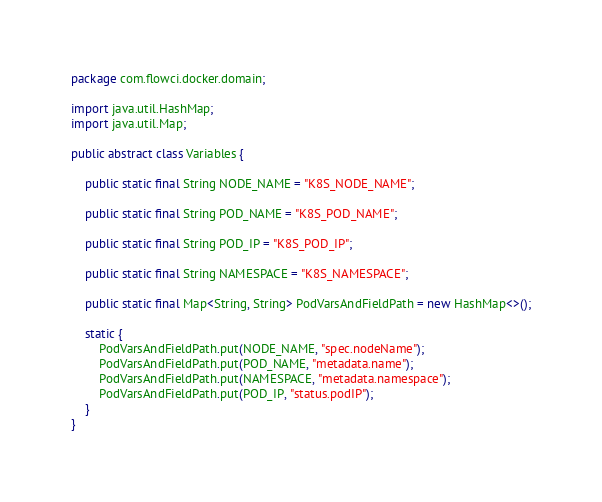Convert code to text. <code><loc_0><loc_0><loc_500><loc_500><_Java_>package com.flowci.docker.domain;

import java.util.HashMap;
import java.util.Map;

public abstract class Variables {

    public static final String NODE_NAME = "K8S_NODE_NAME";

    public static final String POD_NAME = "K8S_POD_NAME";

    public static final String POD_IP = "K8S_POD_IP";

    public static final String NAMESPACE = "K8S_NAMESPACE";

    public static final Map<String, String> PodVarsAndFieldPath = new HashMap<>();

    static {
        PodVarsAndFieldPath.put(NODE_NAME, "spec.nodeName");
        PodVarsAndFieldPath.put(POD_NAME, "metadata.name");
        PodVarsAndFieldPath.put(NAMESPACE, "metadata.namespace");
        PodVarsAndFieldPath.put(POD_IP, "status.podIP");
    }
}
</code> 